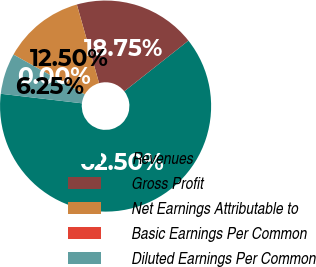<chart> <loc_0><loc_0><loc_500><loc_500><pie_chart><fcel>Revenues<fcel>Gross Profit<fcel>Net Earnings Attributable to<fcel>Basic Earnings Per Common<fcel>Diluted Earnings Per Common<nl><fcel>62.5%<fcel>18.75%<fcel>12.5%<fcel>0.0%<fcel>6.25%<nl></chart> 